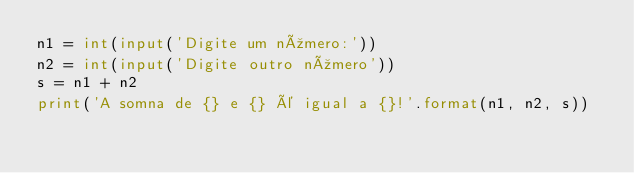Convert code to text. <code><loc_0><loc_0><loc_500><loc_500><_Python_>n1 = int(input('Digite um número:'))
n2 = int(input('Digite outro número'))
s = n1 + n2
print('A somna de {} e {} é igual a {}!'.format(n1, n2, s))




</code> 